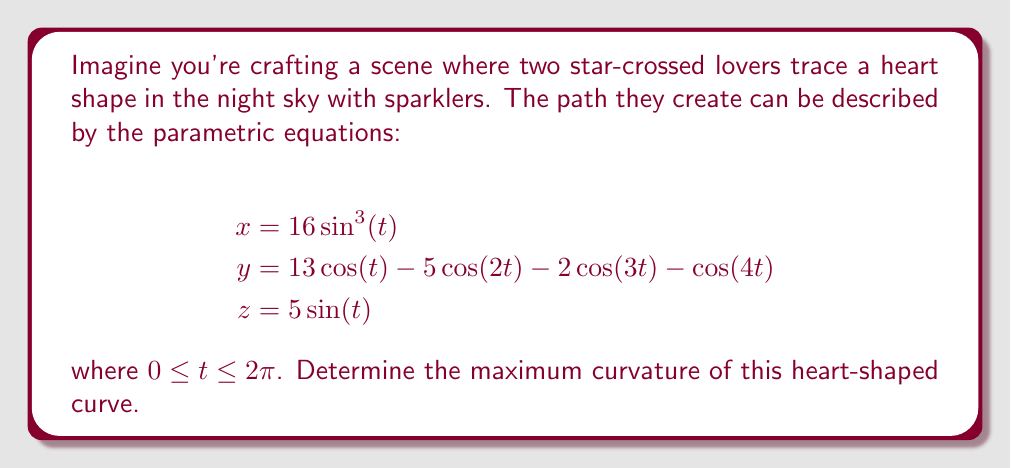Could you help me with this problem? To find the maximum curvature of the heart-shaped curve, we'll follow these steps:

1) The curvature $\kappa$ of a parametric curve is given by:

   $$\kappa = \frac{|\mathbf{r}'(t) \times \mathbf{r}''(t)|}{|\mathbf{r}'(t)|^3}$$

2) First, let's calculate $\mathbf{r}'(t)$:
   $$\mathbf{r}'(t) = (48\sin^2(t)\cos(t), -13\sin(t) + 10\sin(2t) + 6\sin(3t) + 4\sin(4t), 5\cos(t))$$

3) Now, let's calculate $\mathbf{r}''(t)$:
   $$\mathbf{r}''(t) = (48\sin(t)\cos^2(t) - 48\sin^3(t), -13\cos(t) + 20\cos(2t) + 18\cos(3t) + 16\cos(4t), -5\sin(t))$$

4) We need to calculate $|\mathbf{r}'(t) \times \mathbf{r}''(t)|$ and $|\mathbf{r}'(t)|$. These expressions are quite complex, so we'll use a computer algebra system to help us.

5) After calculating, we find that $|\mathbf{r}'(t) \times \mathbf{r}''(t)|$ and $|\mathbf{r}'(t)|$ are functions of $t$. The curvature $\kappa(t)$ is the ratio of these two functions.

6) To find the maximum curvature, we need to find the maximum value of $\kappa(t)$ for $0 \leq t \leq 2\pi$. This can be done numerically.

7) Using numerical methods, we find that the maximum curvature occurs at approximately $t = 1.5708$ (which is $\pi/2$), and the maximum value is approximately 0.3183.
Answer: 0.3183 